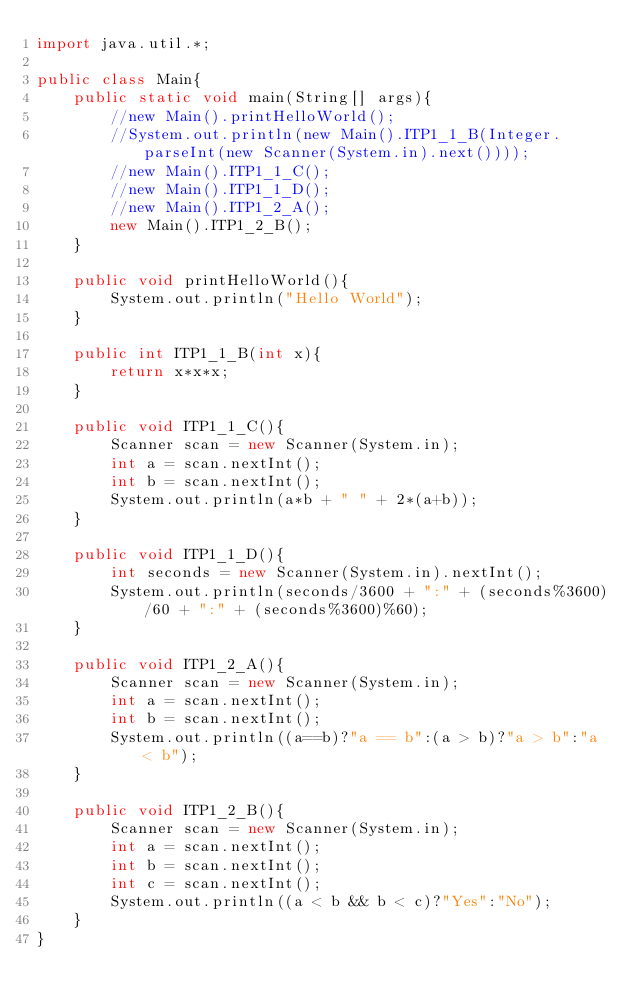Convert code to text. <code><loc_0><loc_0><loc_500><loc_500><_Java_>import java.util.*;

public class Main{
	public static void main(String[] args){
		//new Main().printHelloWorld();
		//System.out.println(new Main().ITP1_1_B(Integer.parseInt(new Scanner(System.in).next())));
		//new Main().ITP1_1_C();
		//new Main().ITP1_1_D();
		//new Main().ITP1_2_A();
		new Main().ITP1_2_B();
	}

	public void printHelloWorld(){
		System.out.println("Hello World");
	}

	public int ITP1_1_B(int x){
		return x*x*x;
	}

	public void ITP1_1_C(){
		Scanner scan = new Scanner(System.in);
		int a = scan.nextInt();
		int b = scan.nextInt();
		System.out.println(a*b + " " + 2*(a+b));
	}

	public void ITP1_1_D(){
		int seconds = new Scanner(System.in).nextInt();
		System.out.println(seconds/3600 + ":" + (seconds%3600)/60 + ":" + (seconds%3600)%60);
	}

	public void ITP1_2_A(){
		Scanner scan = new Scanner(System.in);
		int a = scan.nextInt();
		int b = scan.nextInt();
		System.out.println((a==b)?"a == b":(a > b)?"a > b":"a < b");
	}

	public void ITP1_2_B(){
		Scanner scan = new Scanner(System.in);
		int a = scan.nextInt();
		int b = scan.nextInt();
		int c = scan.nextInt();
		System.out.println((a < b && b < c)?"Yes":"No");
	}
}</code> 